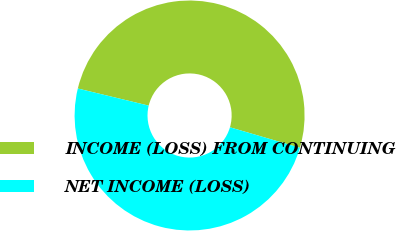Convert chart. <chart><loc_0><loc_0><loc_500><loc_500><pie_chart><fcel>INCOME (LOSS) FROM CONTINUING<fcel>NET INCOME (LOSS)<nl><fcel>50.76%<fcel>49.24%<nl></chart> 